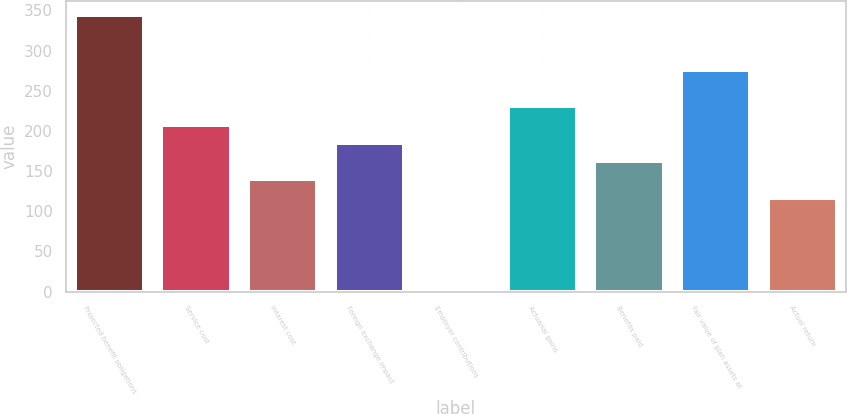Convert chart. <chart><loc_0><loc_0><loc_500><loc_500><bar_chart><fcel>Projected benefit obligations<fcel>Service cost<fcel>Interest cost<fcel>Foreign exchange impact<fcel>Employer contributions<fcel>Actuarial gains<fcel>Benefits paid<fcel>Fair value of plan assets at<fcel>Actual return<nl><fcel>344.65<fcel>207.91<fcel>139.54<fcel>185.12<fcel>2.8<fcel>230.7<fcel>162.33<fcel>276.28<fcel>116.75<nl></chart> 